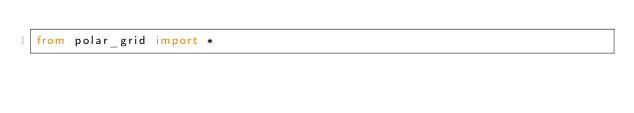<code> <loc_0><loc_0><loc_500><loc_500><_Python_>from polar_grid import *
</code> 